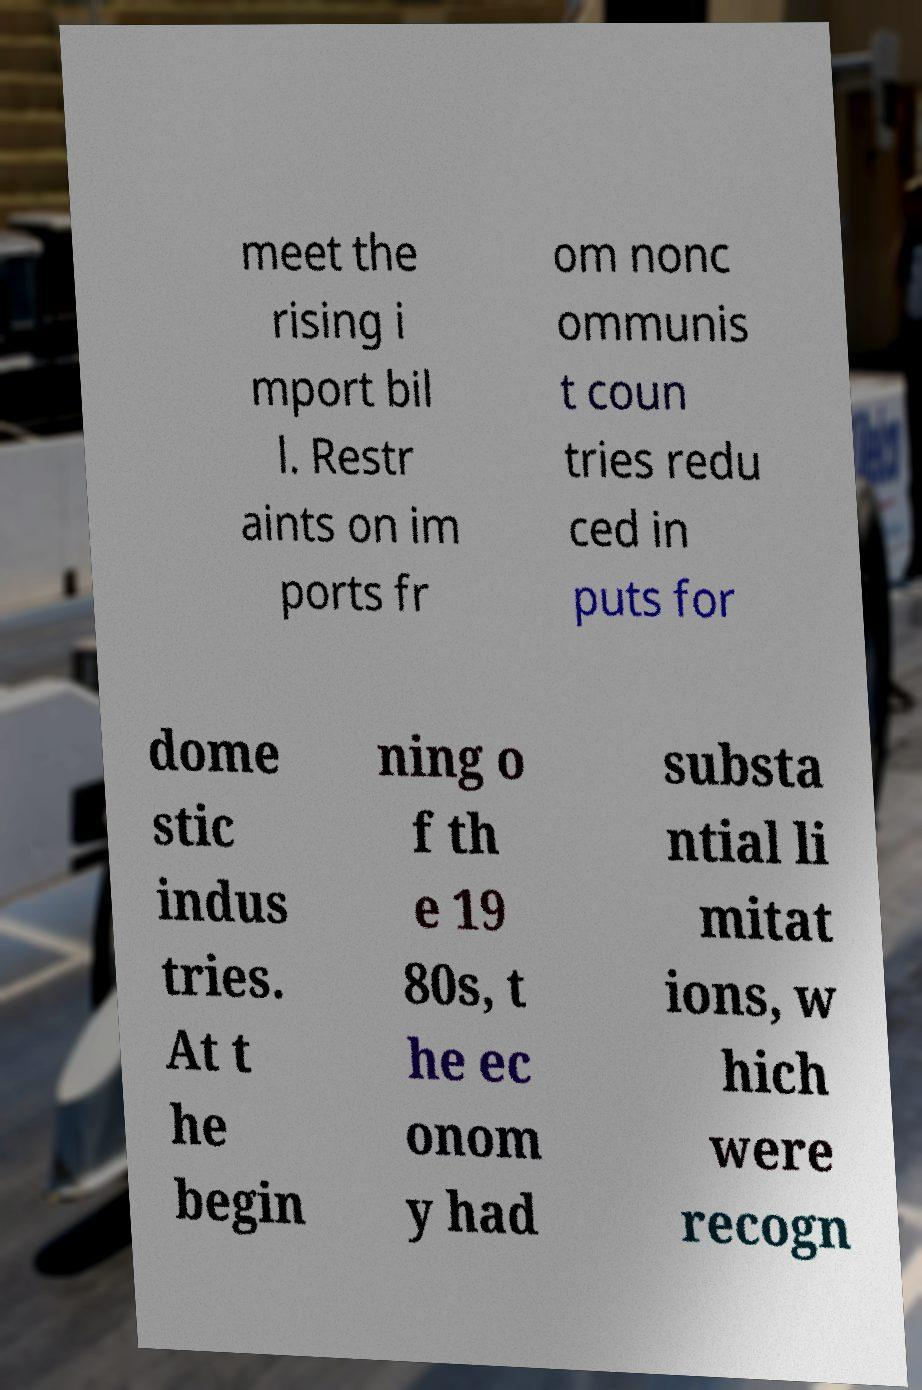Please read and relay the text visible in this image. What does it say? meet the rising i mport bil l. Restr aints on im ports fr om nonc ommunis t coun tries redu ced in puts for dome stic indus tries. At t he begin ning o f th e 19 80s, t he ec onom y had substa ntial li mitat ions, w hich were recogn 